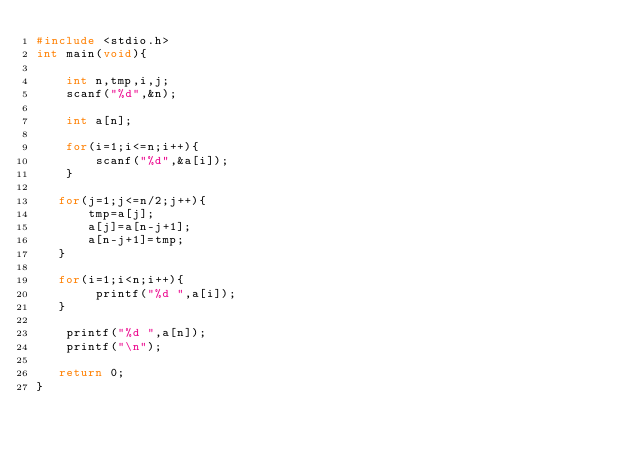Convert code to text. <code><loc_0><loc_0><loc_500><loc_500><_C_>#include <stdio.h>
int main(void){
    
    int n,tmp,i,j;
    scanf("%d",&n);
    
    int a[n];

    for(i=1;i<=n;i++){
        scanf("%d",&a[i]);
    }
   
   for(j=1;j<=n/2;j++){
       tmp=a[j];
       a[j]=a[n-j+1];
       a[n-j+1]=tmp;
   }
   
   for(i=1;i<n;i++){
        printf("%d ",a[i]);
   }
    
    printf("%d ",a[n]);
    printf("\n");
   
   return 0;
}
</code> 